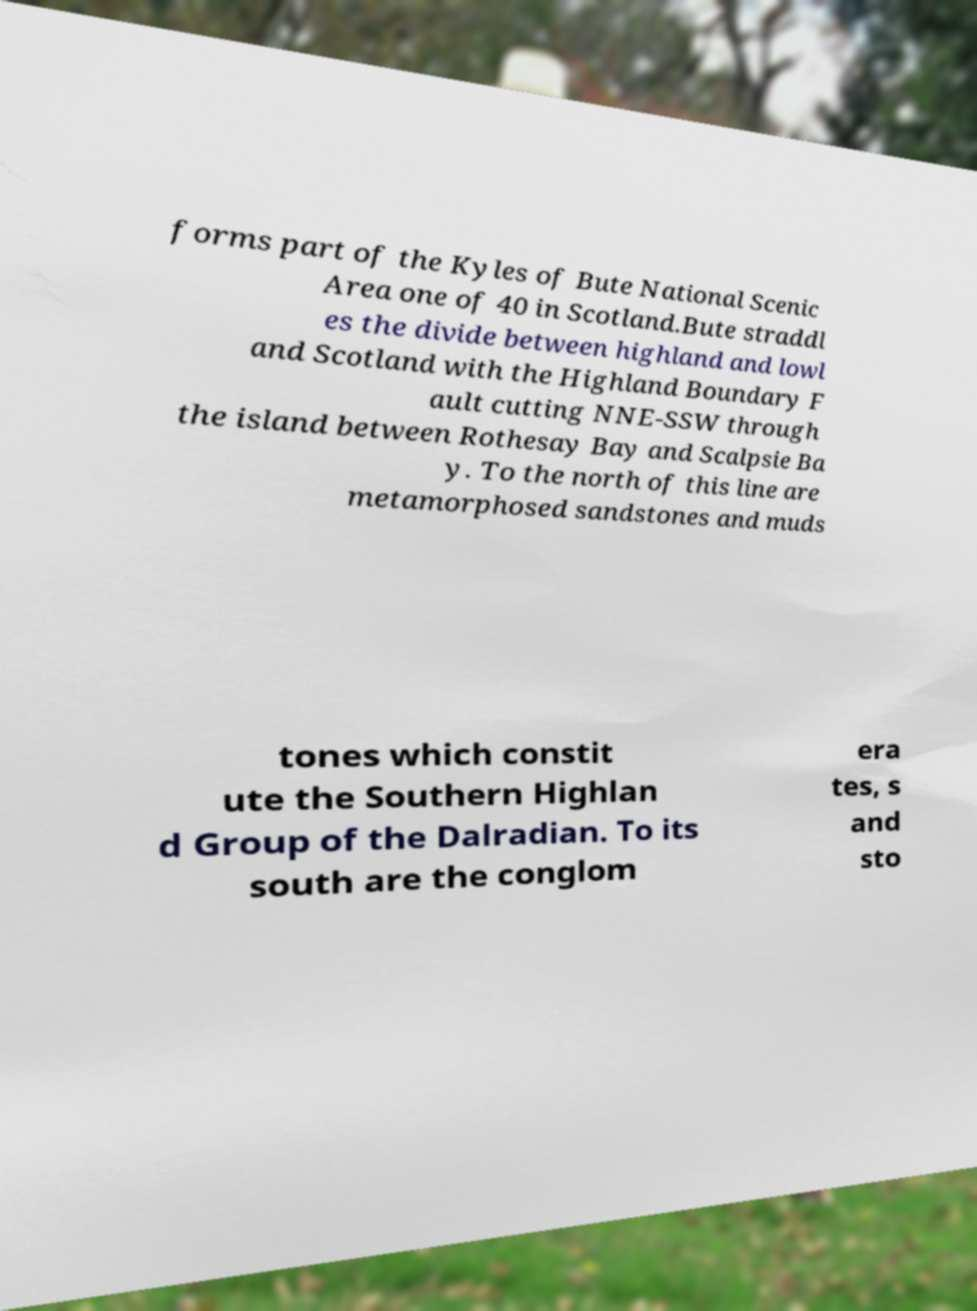Could you assist in decoding the text presented in this image and type it out clearly? forms part of the Kyles of Bute National Scenic Area one of 40 in Scotland.Bute straddl es the divide between highland and lowl and Scotland with the Highland Boundary F ault cutting NNE-SSW through the island between Rothesay Bay and Scalpsie Ba y. To the north of this line are metamorphosed sandstones and muds tones which constit ute the Southern Highlan d Group of the Dalradian. To its south are the conglom era tes, s and sto 